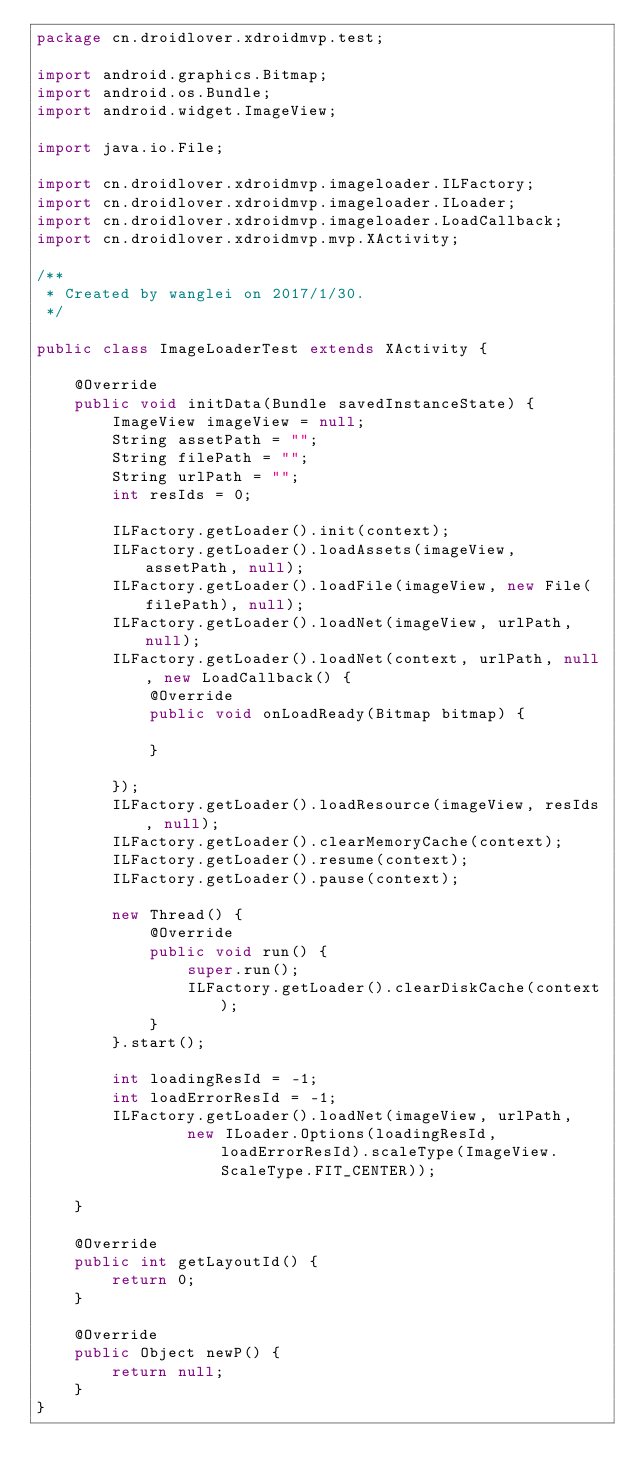Convert code to text. <code><loc_0><loc_0><loc_500><loc_500><_Java_>package cn.droidlover.xdroidmvp.test;

import android.graphics.Bitmap;
import android.os.Bundle;
import android.widget.ImageView;

import java.io.File;

import cn.droidlover.xdroidmvp.imageloader.ILFactory;
import cn.droidlover.xdroidmvp.imageloader.ILoader;
import cn.droidlover.xdroidmvp.imageloader.LoadCallback;
import cn.droidlover.xdroidmvp.mvp.XActivity;

/**
 * Created by wanglei on 2017/1/30.
 */

public class ImageLoaderTest extends XActivity {

    @Override
    public void initData(Bundle savedInstanceState) {
        ImageView imageView = null;
        String assetPath = "";
        String filePath = "";
        String urlPath = "";
        int resIds = 0;

        ILFactory.getLoader().init(context);
        ILFactory.getLoader().loadAssets(imageView, assetPath, null);
        ILFactory.getLoader().loadFile(imageView, new File(filePath), null);
        ILFactory.getLoader().loadNet(imageView, urlPath, null);
        ILFactory.getLoader().loadNet(context, urlPath, null, new LoadCallback() {
            @Override
            public void onLoadReady(Bitmap bitmap) {

            }

        });
        ILFactory.getLoader().loadResource(imageView, resIds, null);
        ILFactory.getLoader().clearMemoryCache(context);
        ILFactory.getLoader().resume(context);
        ILFactory.getLoader().pause(context);

        new Thread() {
            @Override
            public void run() {
                super.run();
                ILFactory.getLoader().clearDiskCache(context);
            }
        }.start();

        int loadingResId = -1;
        int loadErrorResId = -1;
        ILFactory.getLoader().loadNet(imageView, urlPath,
                new ILoader.Options(loadingResId, loadErrorResId).scaleType(ImageView.ScaleType.FIT_CENTER));

    }

    @Override
    public int getLayoutId() {
        return 0;
    }

    @Override
    public Object newP() {
        return null;
    }
}
</code> 